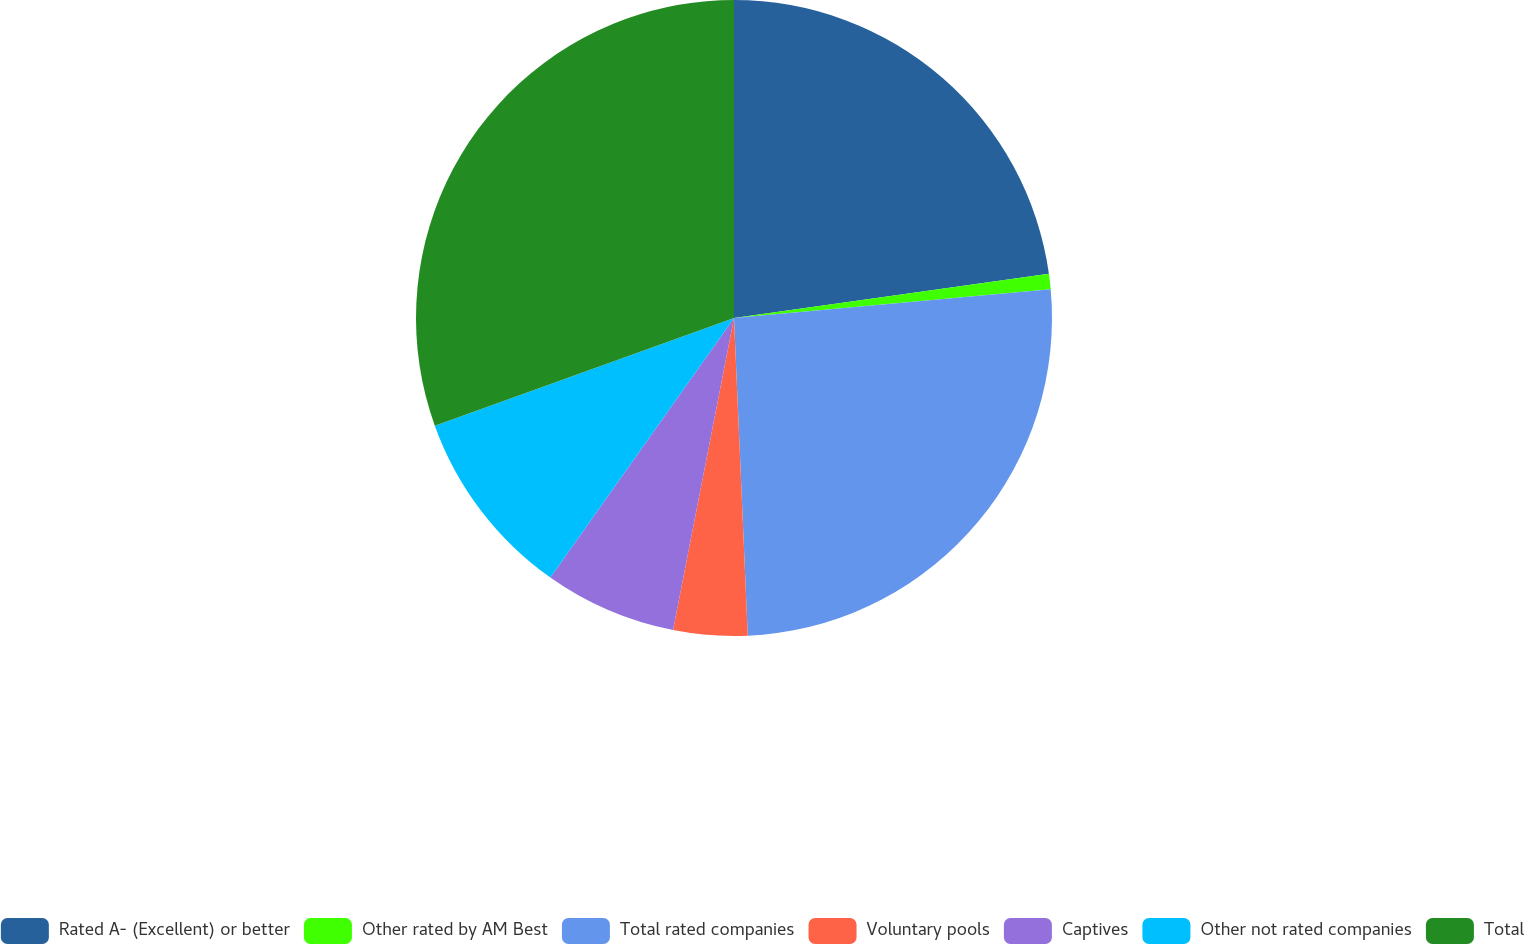Convert chart to OTSL. <chart><loc_0><loc_0><loc_500><loc_500><pie_chart><fcel>Rated A- (Excellent) or better<fcel>Other rated by AM Best<fcel>Total rated companies<fcel>Voluntary pools<fcel>Captives<fcel>Other not rated companies<fcel>Total<nl><fcel>22.78%<fcel>0.78%<fcel>25.75%<fcel>3.76%<fcel>6.73%<fcel>9.7%<fcel>30.5%<nl></chart> 